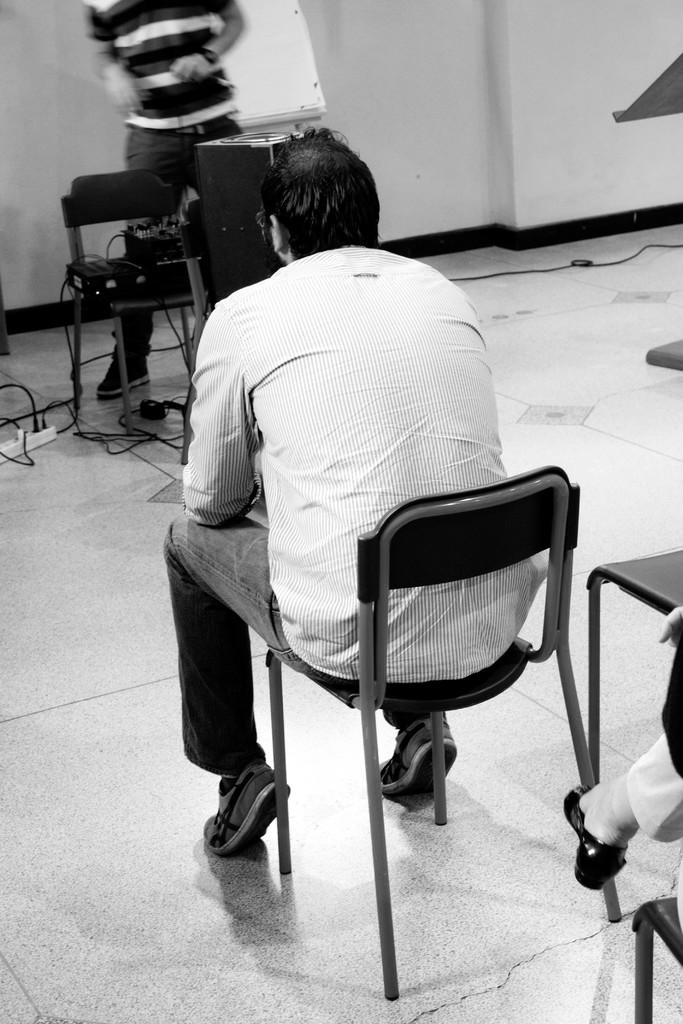What is the position of the person in the image? There is a person sitting on a chair in the image. Is there another person in the image? Yes, there is a person standing in the image. What type of object can be seen in the image? There is an electronic gadget in the image. How many chairs are visible in the image? There are two chairs in the image. What type of cattle can be seen grazing in the image? There are no cattle present in the image; it features a person sitting on a chair, a person standing, an electronic gadget, and two chairs. What kind of meal is being prepared in the image? There is no meal preparation visible in the image. 